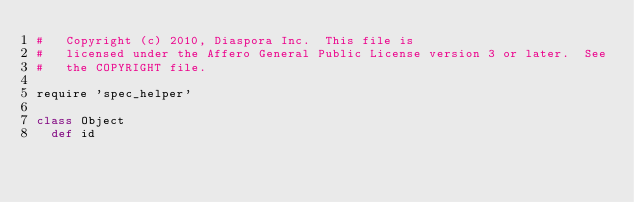<code> <loc_0><loc_0><loc_500><loc_500><_Ruby_>#   Copyright (c) 2010, Diaspora Inc.  This file is
#   licensed under the Affero General Public License version 3 or later.  See
#   the COPYRIGHT file.

require 'spec_helper'

class Object
  def id</code> 